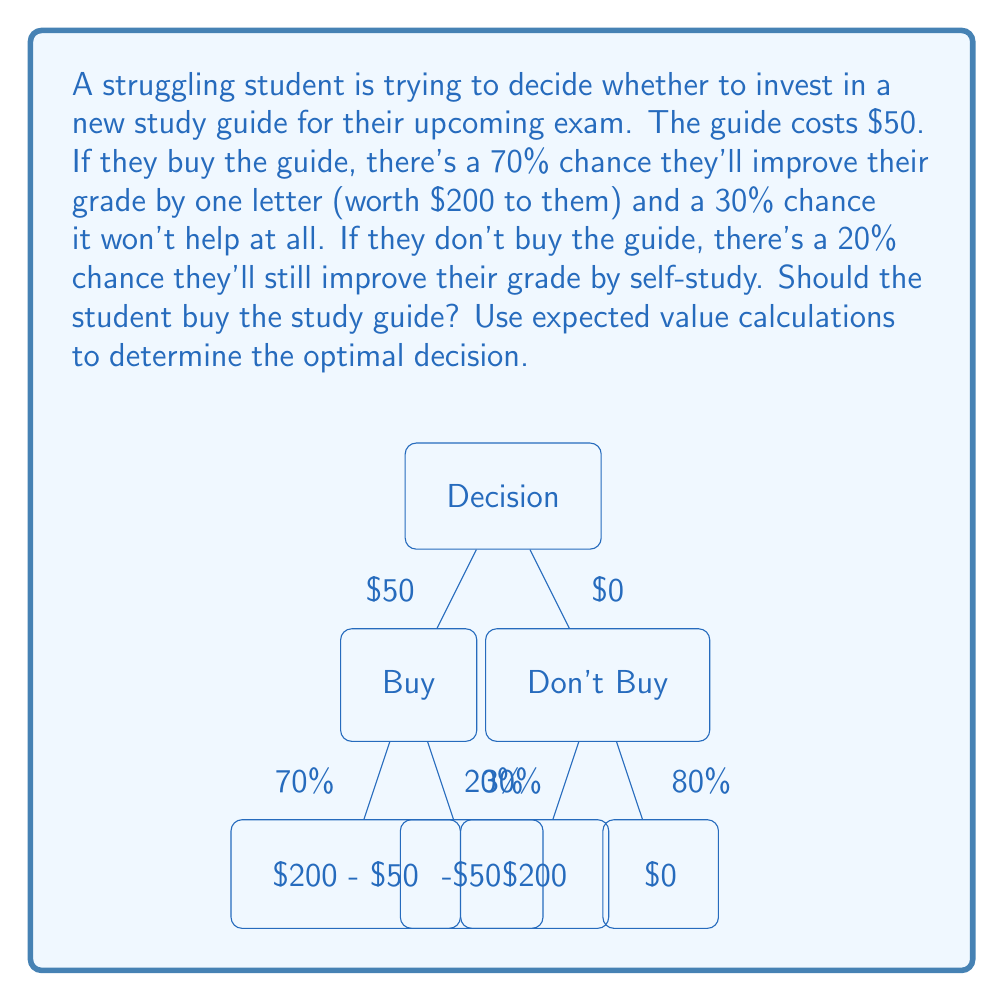Could you help me with this problem? To determine the optimal decision, we need to calculate the expected value for each option and compare them.

1. Expected Value of Buying the Guide:
   $$EV(\text{Buy}) = 0.70 \times ($200 - $50) + 0.30 \times (-$50)$$
   $$EV(\text{Buy}) = 0.70 \times $150 + 0.30 \times (-$50)$$
   $$EV(\text{Buy}) = $105 - $15 = $90$$

2. Expected Value of Not Buying the Guide:
   $$EV(\text{Don't Buy}) = 0.20 \times $200 + 0.80 \times $0$$
   $$EV(\text{Don't Buy}) = $40 + $0 = $40$$

3. Compare the Expected Values:
   The expected value of buying the guide ($90) is greater than the expected value of not buying the guide ($40).

Therefore, the optimal decision based on expected value calculations is to buy the study guide.
Answer: Buy the study guide 